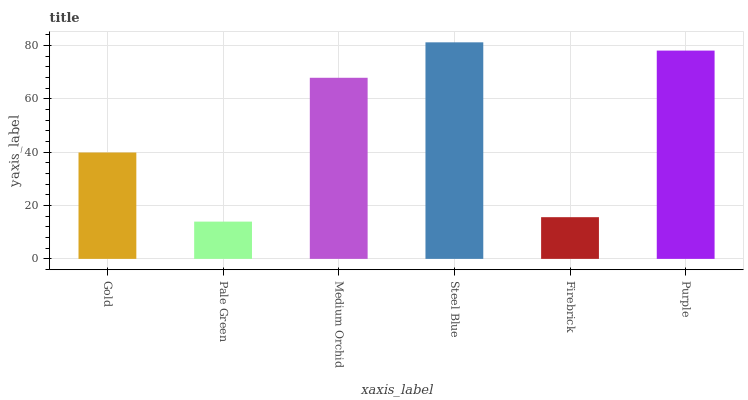Is Pale Green the minimum?
Answer yes or no. Yes. Is Steel Blue the maximum?
Answer yes or no. Yes. Is Medium Orchid the minimum?
Answer yes or no. No. Is Medium Orchid the maximum?
Answer yes or no. No. Is Medium Orchid greater than Pale Green?
Answer yes or no. Yes. Is Pale Green less than Medium Orchid?
Answer yes or no. Yes. Is Pale Green greater than Medium Orchid?
Answer yes or no. No. Is Medium Orchid less than Pale Green?
Answer yes or no. No. Is Medium Orchid the high median?
Answer yes or no. Yes. Is Gold the low median?
Answer yes or no. Yes. Is Purple the high median?
Answer yes or no. No. Is Purple the low median?
Answer yes or no. No. 